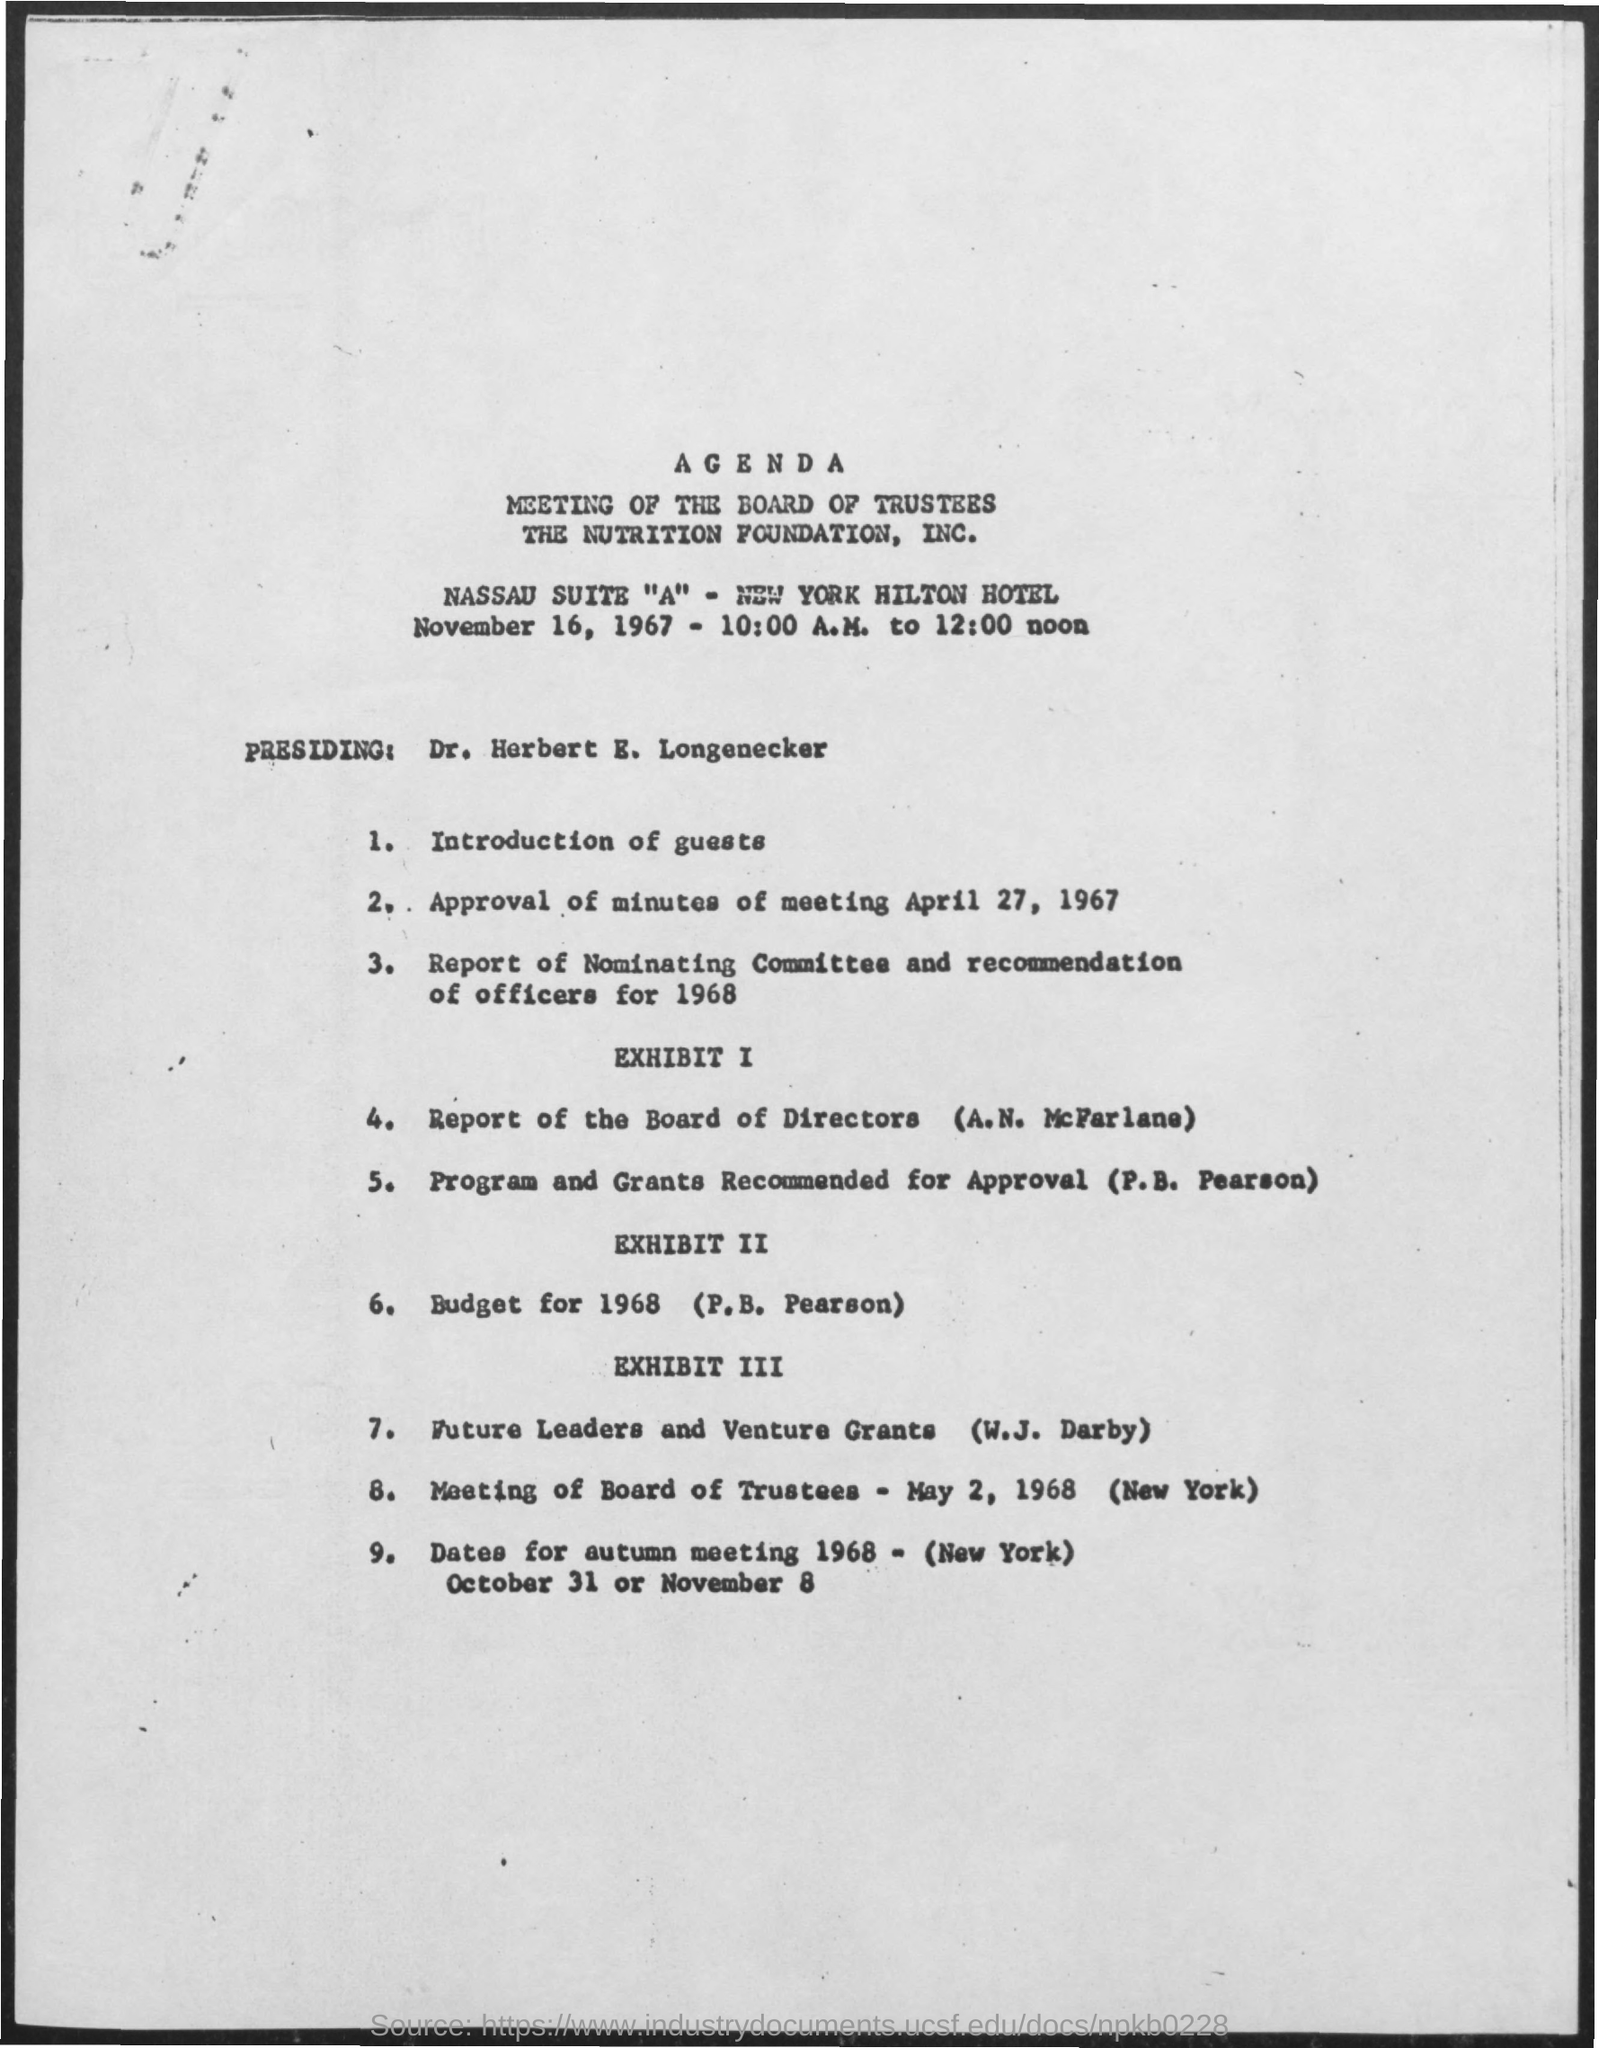Give some essential details in this illustration. The time mentioned in the given form is 10:00 A.M. to 12:00 noon. 